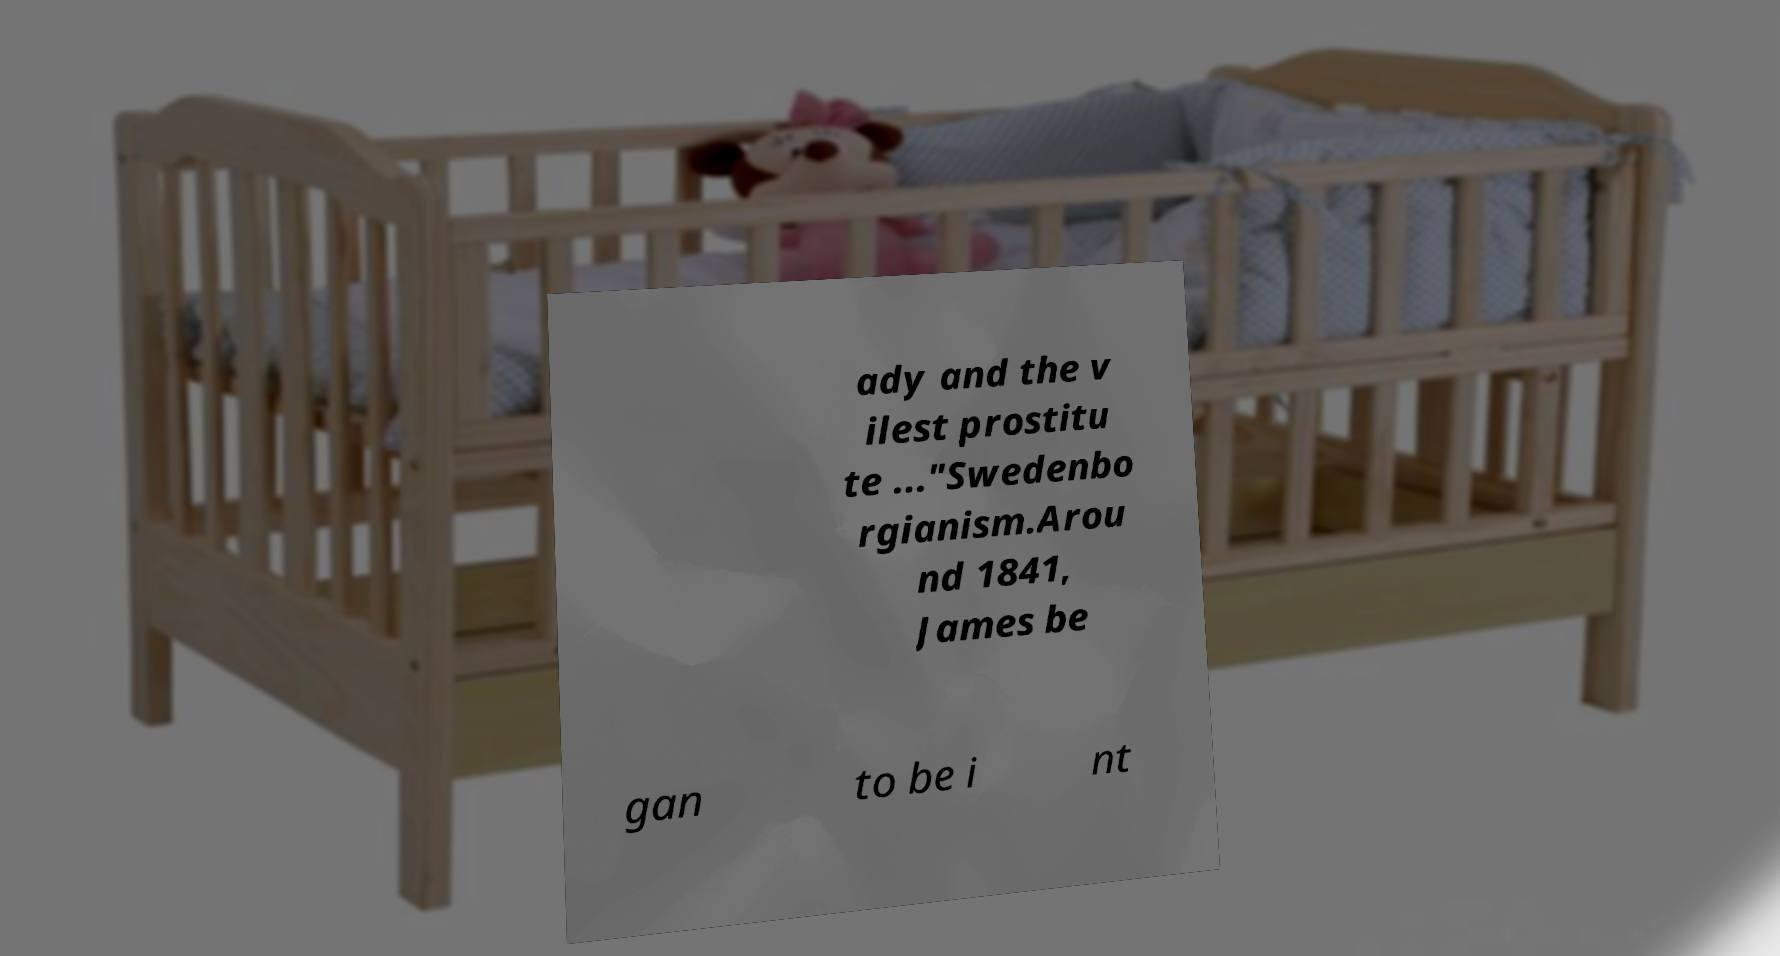For documentation purposes, I need the text within this image transcribed. Could you provide that? ady and the v ilest prostitu te ..."Swedenbo rgianism.Arou nd 1841, James be gan to be i nt 